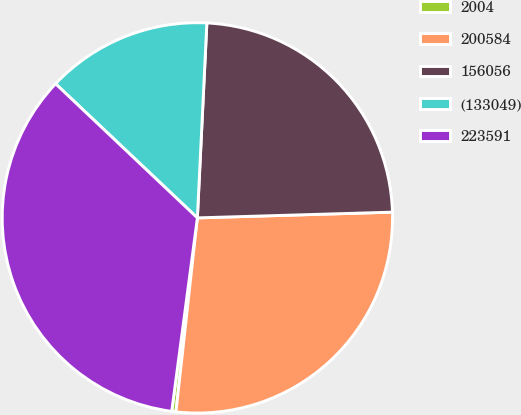Convert chart. <chart><loc_0><loc_0><loc_500><loc_500><pie_chart><fcel>2004<fcel>200584<fcel>156056<fcel>(133049)<fcel>223591<nl><fcel>0.35%<fcel>27.22%<fcel>23.76%<fcel>13.72%<fcel>34.96%<nl></chart> 